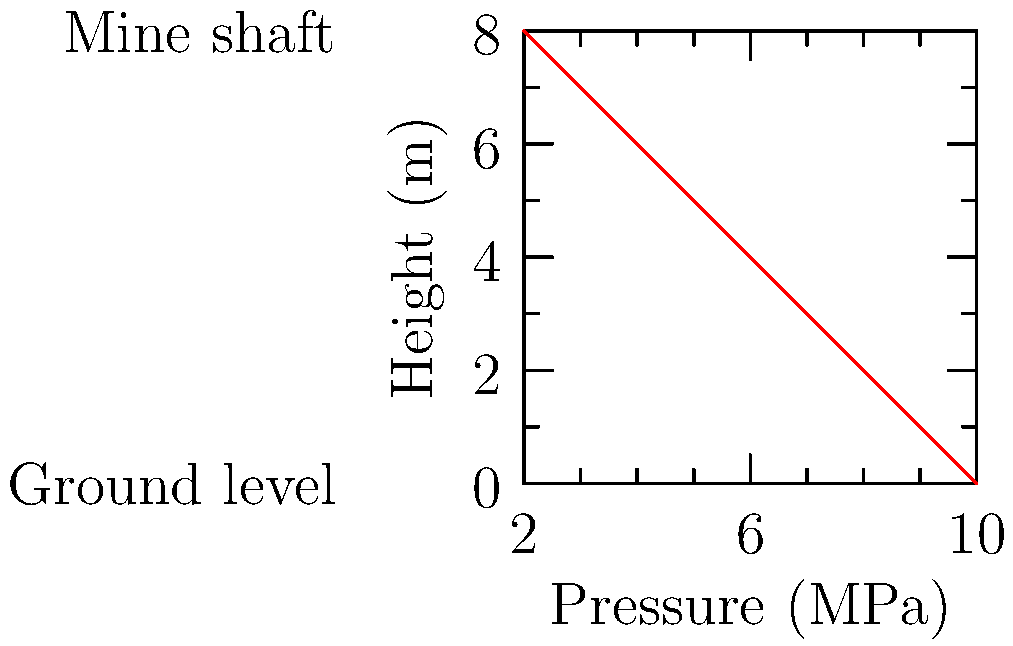In a hydraulic support system for a mine shaft, the pressure decreases linearly with height as shown in the graph. If the pressure at the bottom of the 8-meter shaft is 10 MPa, what is the rate of pressure change with respect to height? To find the rate of pressure change with respect to height, we need to follow these steps:

1. Identify the change in pressure (Δp):
   Pressure at bottom = 10 MPa
   Pressure at top = 2 MPa
   Δp = 10 MPa - 2 MPa = 8 MPa

2. Identify the change in height (Δh):
   Height of shaft = 8 m
   Δh = 8 m

3. Calculate the rate of pressure change:
   Rate = Δp / Δh
   Rate = 8 MPa / 8 m
   Rate = 1 MPa/m

4. Express the rate as a negative value since pressure decreases with increasing height:
   Rate = -1 MPa/m

Therefore, the rate of pressure change with respect to height is -1 MPa/m.
Answer: $-1 \text{ MPa/m}$ 